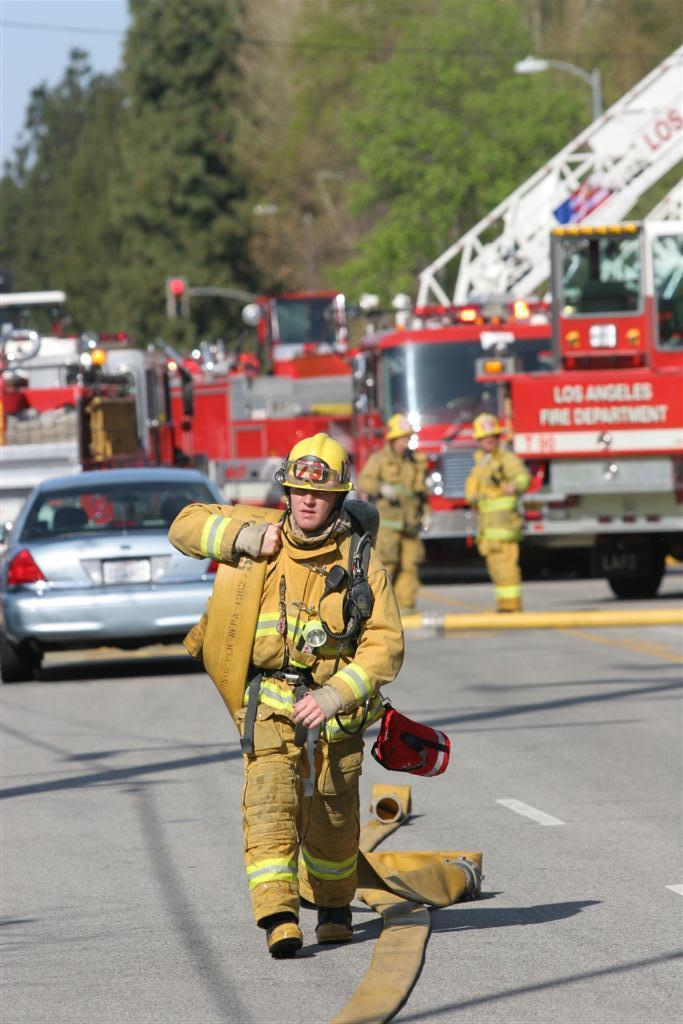<image>
Write a terse but informative summary of the picture. A firefighter in yellow in front of a vehicle reading Los Angeles Fire Department. 